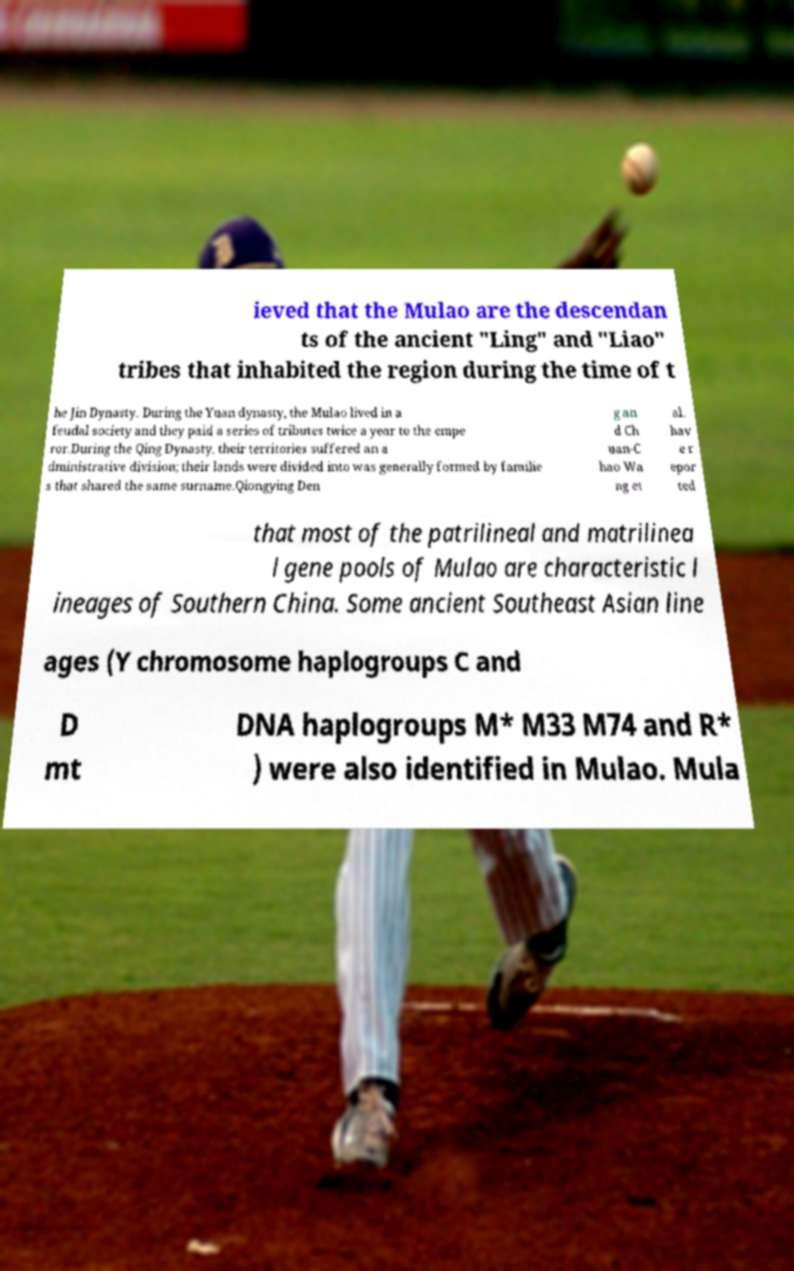Please identify and transcribe the text found in this image. ieved that the Mulao are the descendan ts of the ancient "Ling" and "Liao" tribes that inhabited the region during the time of t he Jin Dynasty. During the Yuan dynasty, the Mulao lived in a feudal society and they paid a series of tributes twice a year to the empe ror.During the Qing Dynasty, their territories suffered an a dministrative division; their lands were divided into was generally formed by familie s that shared the same surname.Qiongying Den g an d Ch uan-C hao Wa ng et al. hav e r epor ted that most of the patrilineal and matrilinea l gene pools of Mulao are characteristic l ineages of Southern China. Some ancient Southeast Asian line ages (Y chromosome haplogroups C and D mt DNA haplogroups M* M33 M74 and R* ) were also identified in Mulao. Mula 